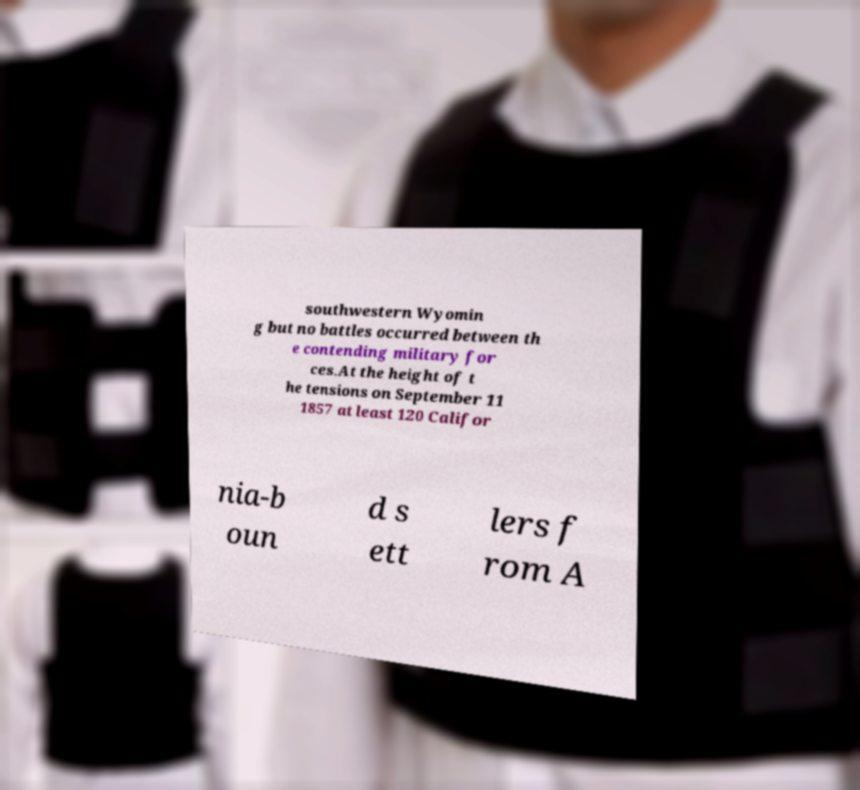Please identify and transcribe the text found in this image. southwestern Wyomin g but no battles occurred between th e contending military for ces.At the height of t he tensions on September 11 1857 at least 120 Califor nia-b oun d s ett lers f rom A 